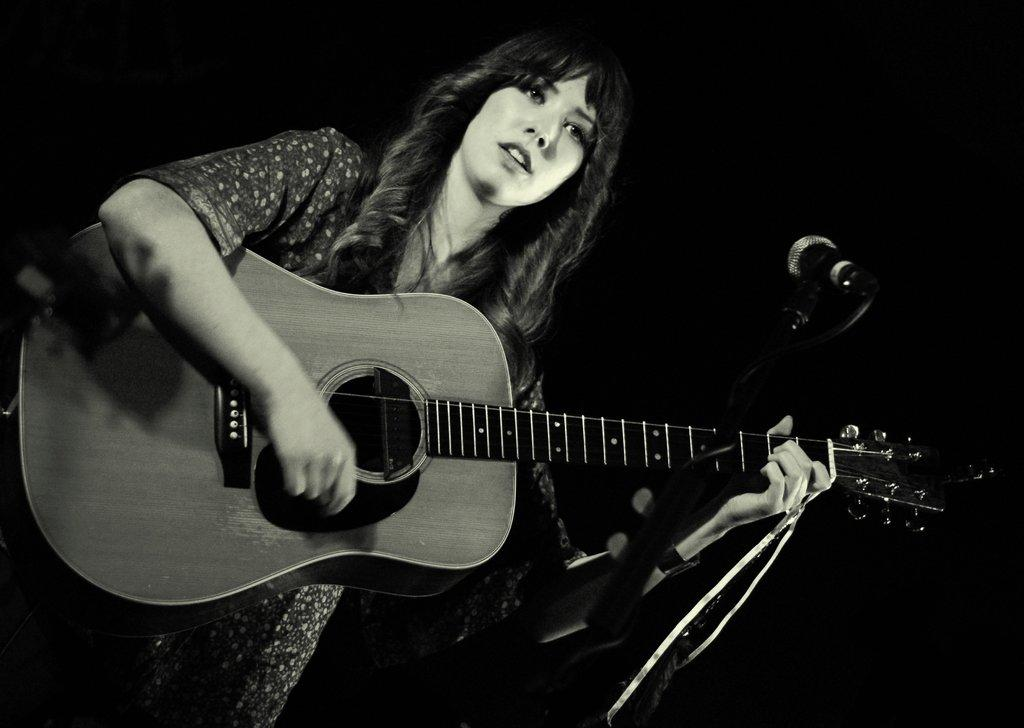Who is the main subject in the image? There is a lady in the image. What is the lady doing in the image? The lady is standing and playing the guitar with her hands. What type of balloon is the lady holding in the image? There is no balloon present in the image; the lady is playing the guitar with her hands. 